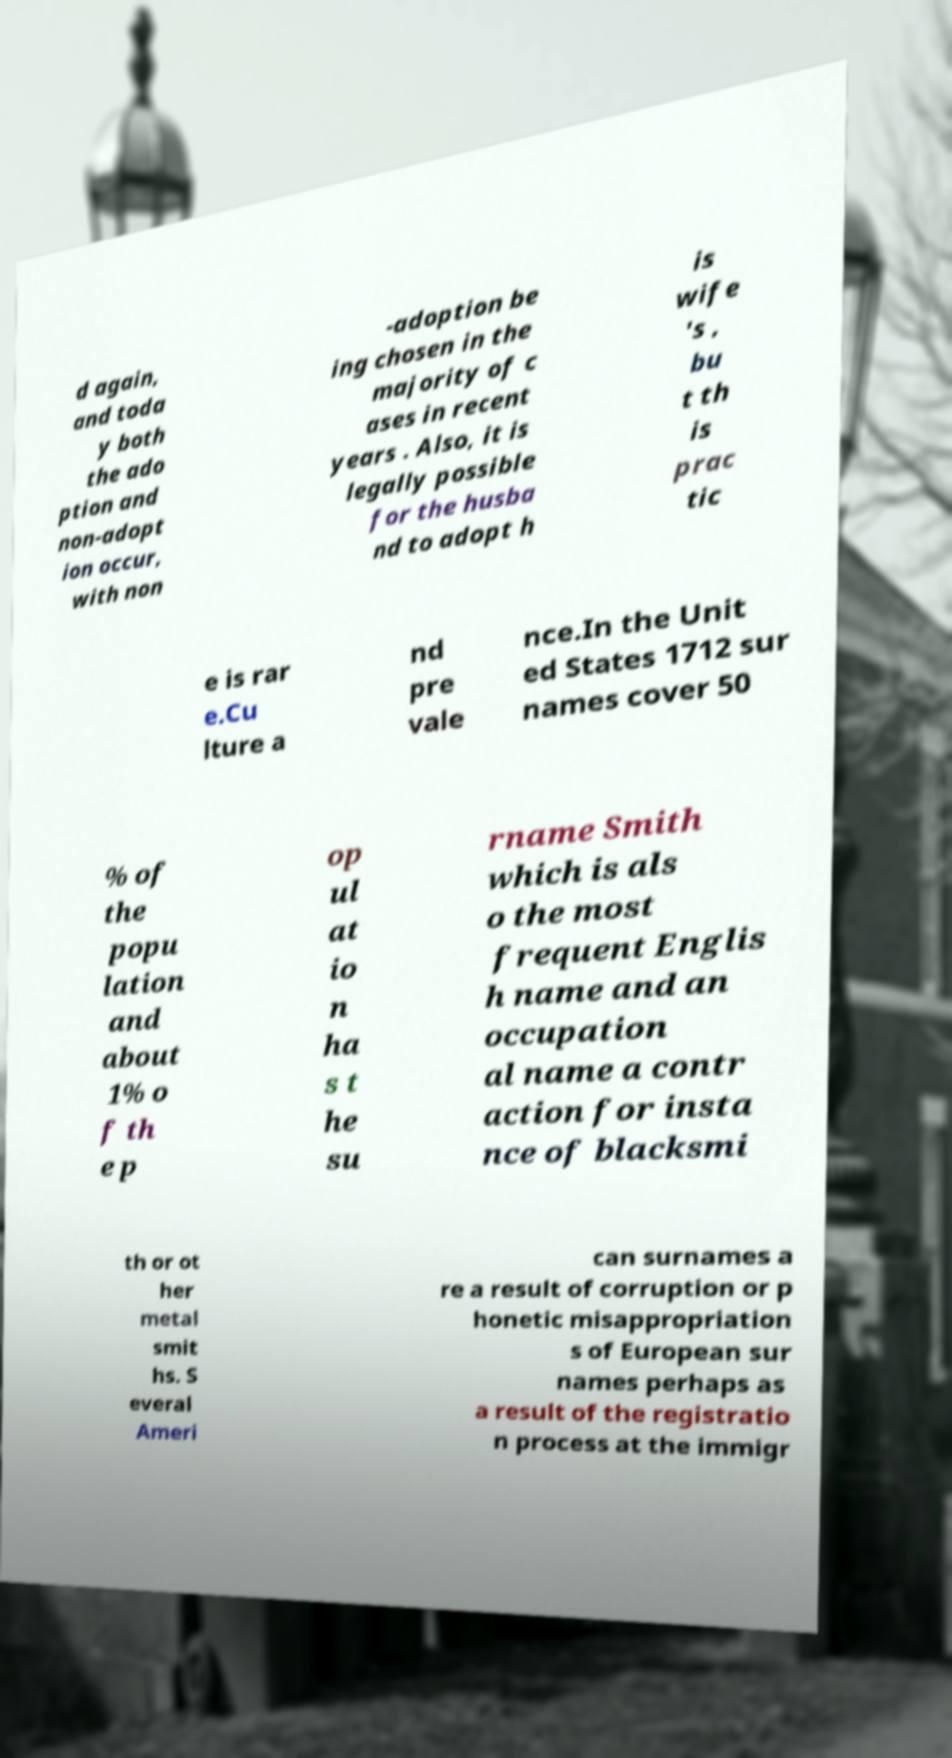What messages or text are displayed in this image? I need them in a readable, typed format. d again, and toda y both the ado ption and non-adopt ion occur, with non -adoption be ing chosen in the majority of c ases in recent years . Also, it is legally possible for the husba nd to adopt h is wife 's , bu t th is prac tic e is rar e.Cu lture a nd pre vale nce.In the Unit ed States 1712 sur names cover 50 % of the popu lation and about 1% o f th e p op ul at io n ha s t he su rname Smith which is als o the most frequent Englis h name and an occupation al name a contr action for insta nce of blacksmi th or ot her metal smit hs. S everal Ameri can surnames a re a result of corruption or p honetic misappropriation s of European sur names perhaps as a result of the registratio n process at the immigr 